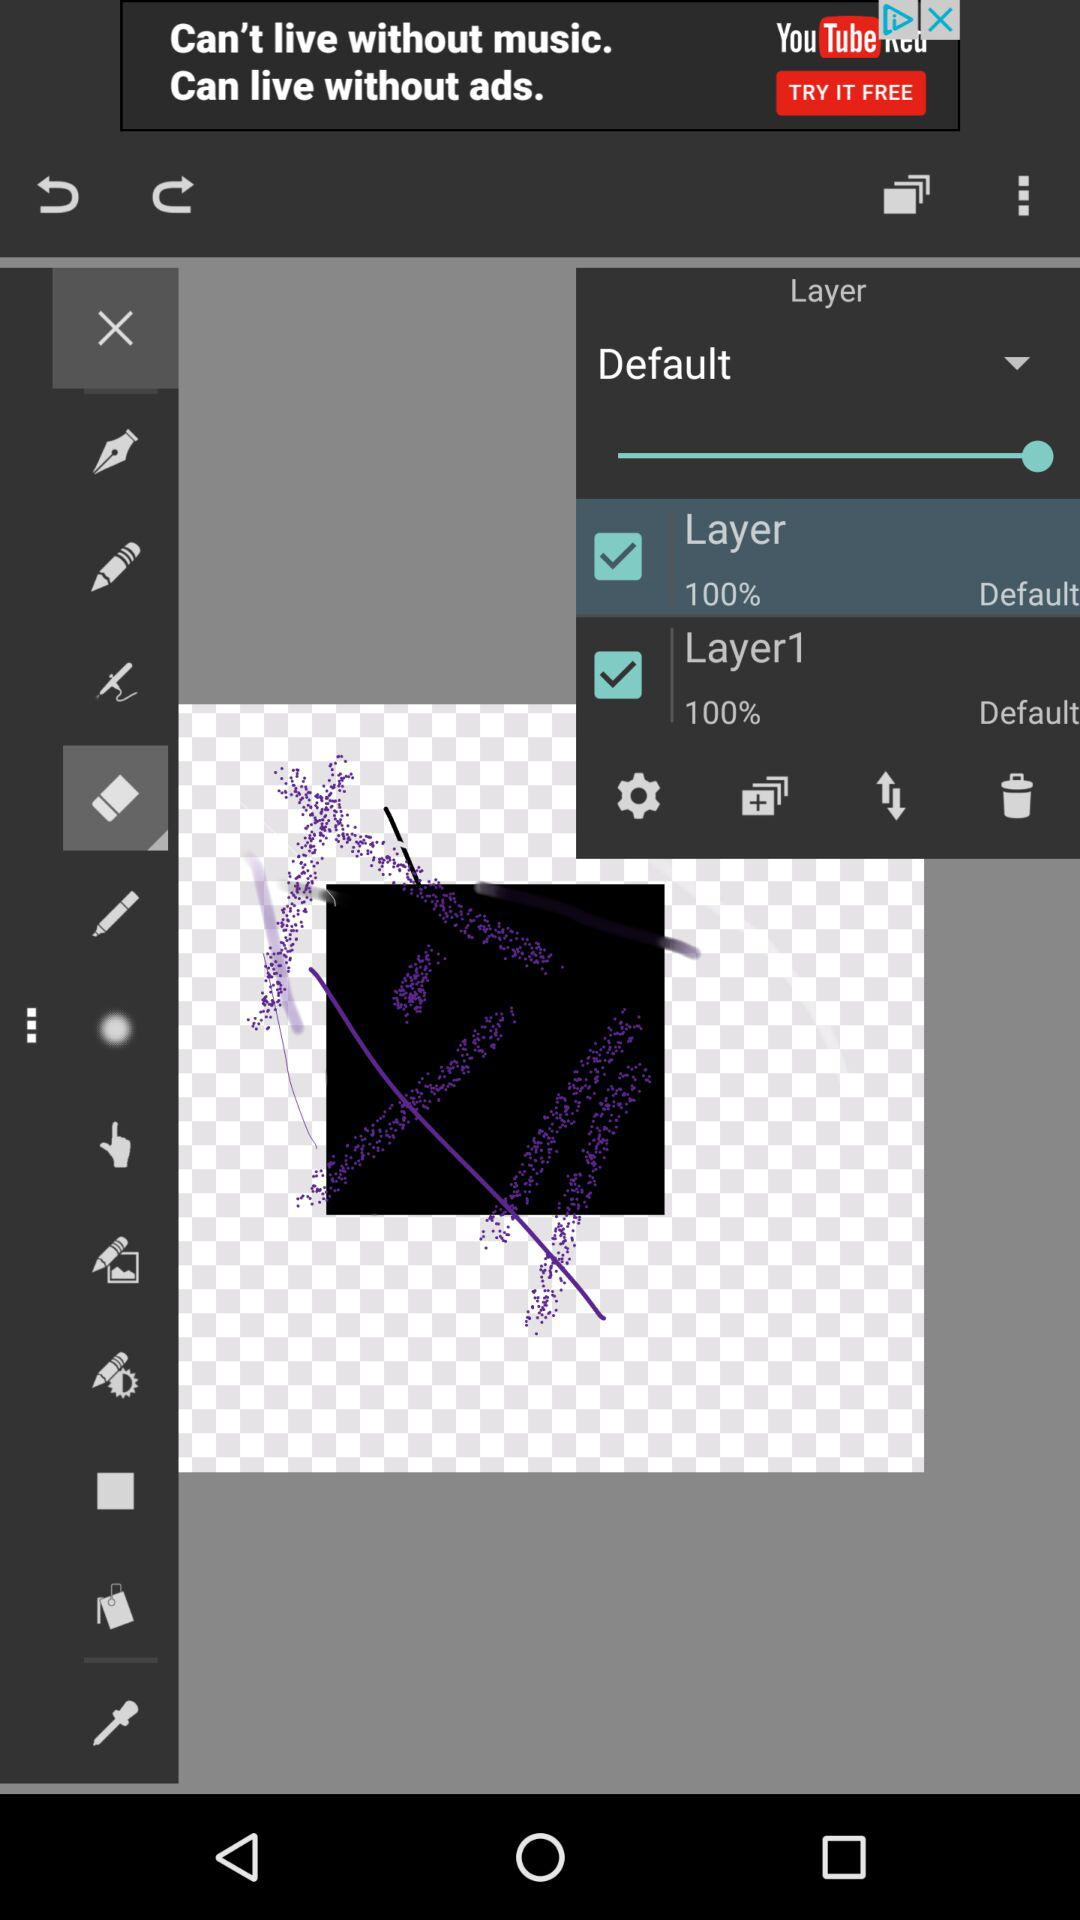What's the percentage of Layer1? The percentage of Layer1 is 100. 